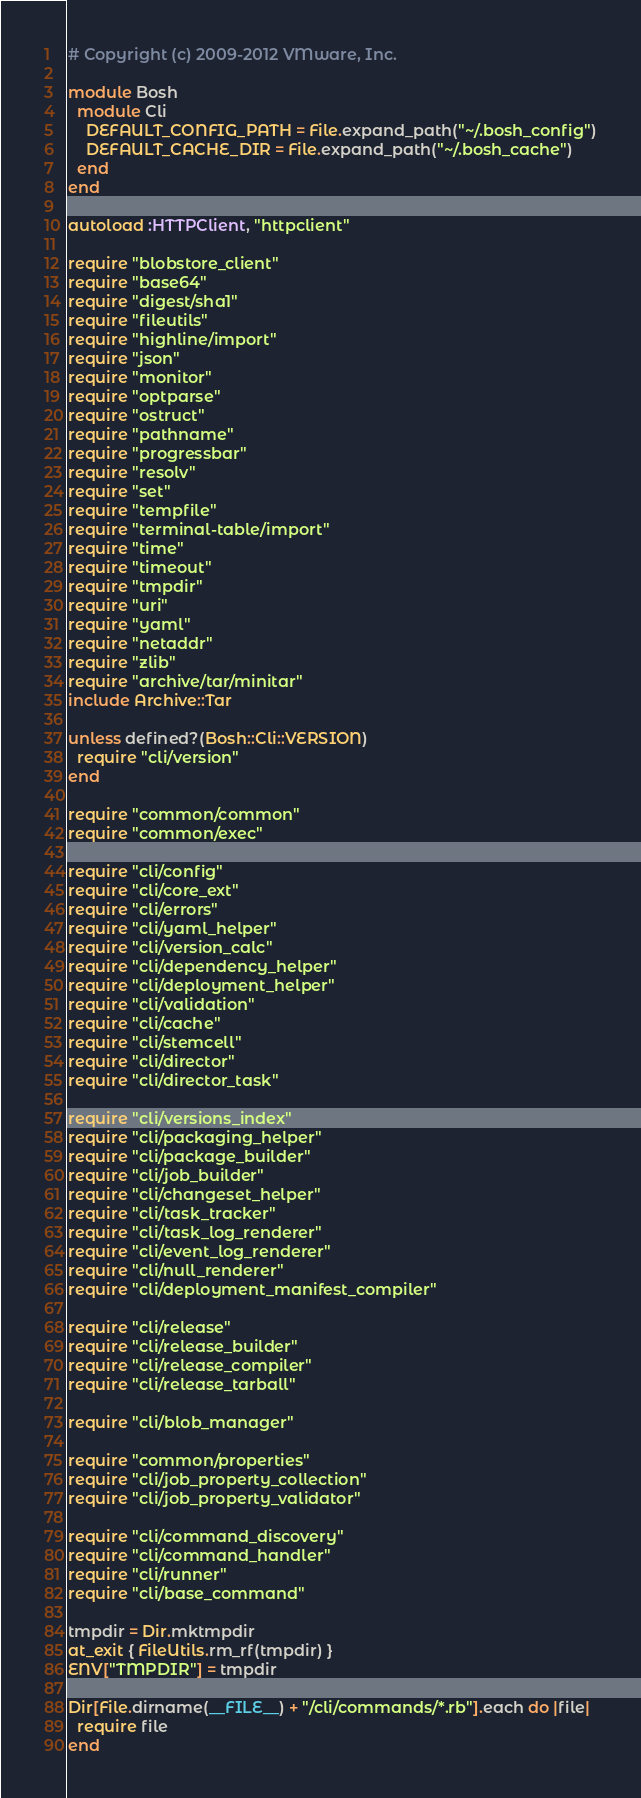<code> <loc_0><loc_0><loc_500><loc_500><_Ruby_># Copyright (c) 2009-2012 VMware, Inc.

module Bosh
  module Cli
    DEFAULT_CONFIG_PATH = File.expand_path("~/.bosh_config")
    DEFAULT_CACHE_DIR = File.expand_path("~/.bosh_cache")
  end
end

autoload :HTTPClient, "httpclient"

require "blobstore_client"
require "base64"
require "digest/sha1"
require "fileutils"
require "highline/import"
require "json"
require "monitor"
require "optparse"
require "ostruct"
require "pathname"
require "progressbar"
require "resolv"
require "set"
require "tempfile"
require "terminal-table/import"
require "time"
require "timeout"
require "tmpdir"
require "uri"
require "yaml"
require "netaddr"
require "zlib"
require "archive/tar/minitar"
include Archive::Tar

unless defined?(Bosh::Cli::VERSION)
  require "cli/version"
end

require "common/common"
require "common/exec"

require "cli/config"
require "cli/core_ext"
require "cli/errors"
require "cli/yaml_helper"
require "cli/version_calc"
require "cli/dependency_helper"
require "cli/deployment_helper"
require "cli/validation"
require "cli/cache"
require "cli/stemcell"
require "cli/director"
require "cli/director_task"

require "cli/versions_index"
require "cli/packaging_helper"
require "cli/package_builder"
require "cli/job_builder"
require "cli/changeset_helper"
require "cli/task_tracker"
require "cli/task_log_renderer"
require "cli/event_log_renderer"
require "cli/null_renderer"
require "cli/deployment_manifest_compiler"

require "cli/release"
require "cli/release_builder"
require "cli/release_compiler"
require "cli/release_tarball"

require "cli/blob_manager"

require "common/properties"
require "cli/job_property_collection"
require "cli/job_property_validator"

require "cli/command_discovery"
require "cli/command_handler"
require "cli/runner"
require "cli/base_command"

tmpdir = Dir.mktmpdir
at_exit { FileUtils.rm_rf(tmpdir) }
ENV["TMPDIR"] = tmpdir

Dir[File.dirname(__FILE__) + "/cli/commands/*.rb"].each do |file|
  require file
end
</code> 